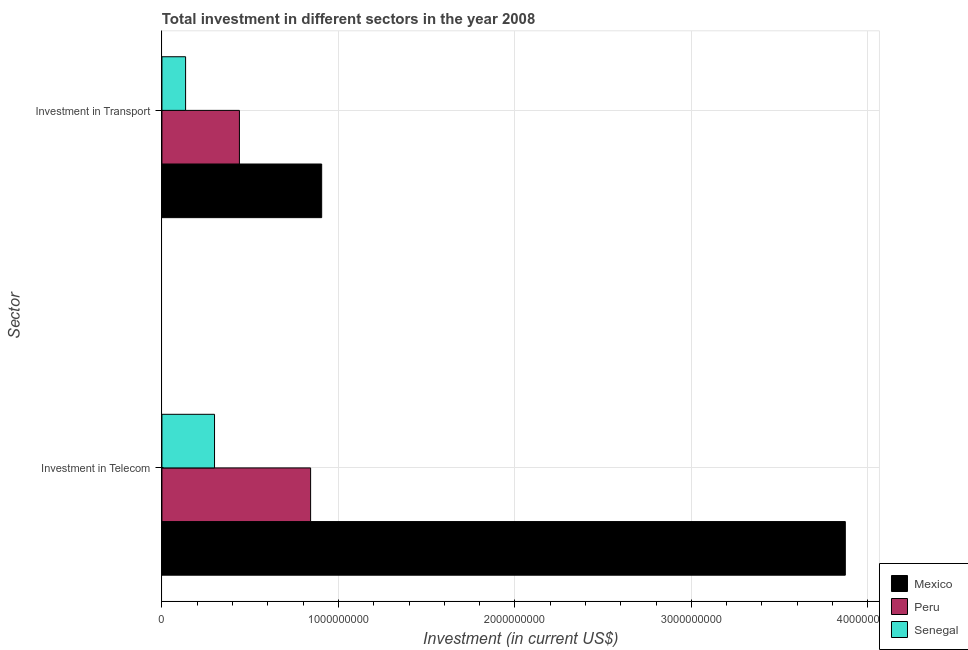How many groups of bars are there?
Give a very brief answer. 2. Are the number of bars per tick equal to the number of legend labels?
Provide a succinct answer. Yes. How many bars are there on the 1st tick from the top?
Give a very brief answer. 3. What is the label of the 2nd group of bars from the top?
Your answer should be compact. Investment in Telecom. What is the investment in telecom in Mexico?
Offer a terse response. 3.87e+09. Across all countries, what is the maximum investment in transport?
Offer a terse response. 9.05e+08. Across all countries, what is the minimum investment in telecom?
Provide a succinct answer. 2.98e+08. In which country was the investment in telecom minimum?
Offer a very short reply. Senegal. What is the total investment in telecom in the graph?
Your answer should be very brief. 5.01e+09. What is the difference between the investment in telecom in Peru and that in Senegal?
Provide a short and direct response. 5.44e+08. What is the difference between the investment in transport in Senegal and the investment in telecom in Peru?
Your answer should be compact. -7.08e+08. What is the average investment in telecom per country?
Your answer should be very brief. 1.67e+09. What is the difference between the investment in telecom and investment in transport in Mexico?
Offer a very short reply. 2.97e+09. What is the ratio of the investment in transport in Peru to that in Senegal?
Your answer should be very brief. 3.28. Is the investment in telecom in Peru less than that in Senegal?
Your response must be concise. No. In how many countries, is the investment in transport greater than the average investment in transport taken over all countries?
Provide a short and direct response. 1. What does the 3rd bar from the top in Investment in Telecom represents?
Your answer should be compact. Mexico. What does the 1st bar from the bottom in Investment in Transport represents?
Offer a terse response. Mexico. What is the difference between two consecutive major ticks on the X-axis?
Offer a very short reply. 1.00e+09. Does the graph contain any zero values?
Give a very brief answer. No. Does the graph contain grids?
Make the answer very short. Yes. Where does the legend appear in the graph?
Make the answer very short. Bottom right. What is the title of the graph?
Offer a very short reply. Total investment in different sectors in the year 2008. What is the label or title of the X-axis?
Provide a succinct answer. Investment (in current US$). What is the label or title of the Y-axis?
Your answer should be compact. Sector. What is the Investment (in current US$) in Mexico in Investment in Telecom?
Your response must be concise. 3.87e+09. What is the Investment (in current US$) in Peru in Investment in Telecom?
Provide a short and direct response. 8.42e+08. What is the Investment (in current US$) in Senegal in Investment in Telecom?
Keep it short and to the point. 2.98e+08. What is the Investment (in current US$) in Mexico in Investment in Transport?
Offer a very short reply. 9.05e+08. What is the Investment (in current US$) of Peru in Investment in Transport?
Provide a short and direct response. 4.39e+08. What is the Investment (in current US$) in Senegal in Investment in Transport?
Keep it short and to the point. 1.34e+08. Across all Sector, what is the maximum Investment (in current US$) of Mexico?
Provide a short and direct response. 3.87e+09. Across all Sector, what is the maximum Investment (in current US$) in Peru?
Your response must be concise. 8.42e+08. Across all Sector, what is the maximum Investment (in current US$) in Senegal?
Provide a succinct answer. 2.98e+08. Across all Sector, what is the minimum Investment (in current US$) of Mexico?
Your answer should be compact. 9.05e+08. Across all Sector, what is the minimum Investment (in current US$) of Peru?
Your answer should be very brief. 4.39e+08. Across all Sector, what is the minimum Investment (in current US$) of Senegal?
Your answer should be very brief. 1.34e+08. What is the total Investment (in current US$) of Mexico in the graph?
Your response must be concise. 4.78e+09. What is the total Investment (in current US$) in Peru in the graph?
Your response must be concise. 1.28e+09. What is the total Investment (in current US$) of Senegal in the graph?
Keep it short and to the point. 4.32e+08. What is the difference between the Investment (in current US$) of Mexico in Investment in Telecom and that in Investment in Transport?
Your response must be concise. 2.97e+09. What is the difference between the Investment (in current US$) of Peru in Investment in Telecom and that in Investment in Transport?
Give a very brief answer. 4.03e+08. What is the difference between the Investment (in current US$) in Senegal in Investment in Telecom and that in Investment in Transport?
Your response must be concise. 1.64e+08. What is the difference between the Investment (in current US$) in Mexico in Investment in Telecom and the Investment (in current US$) in Peru in Investment in Transport?
Give a very brief answer. 3.43e+09. What is the difference between the Investment (in current US$) of Mexico in Investment in Telecom and the Investment (in current US$) of Senegal in Investment in Transport?
Provide a short and direct response. 3.74e+09. What is the difference between the Investment (in current US$) in Peru in Investment in Telecom and the Investment (in current US$) in Senegal in Investment in Transport?
Offer a very short reply. 7.08e+08. What is the average Investment (in current US$) of Mexico per Sector?
Provide a succinct answer. 2.39e+09. What is the average Investment (in current US$) in Peru per Sector?
Give a very brief answer. 6.41e+08. What is the average Investment (in current US$) in Senegal per Sector?
Offer a very short reply. 2.16e+08. What is the difference between the Investment (in current US$) in Mexico and Investment (in current US$) in Peru in Investment in Telecom?
Offer a very short reply. 3.03e+09. What is the difference between the Investment (in current US$) in Mexico and Investment (in current US$) in Senegal in Investment in Telecom?
Give a very brief answer. 3.57e+09. What is the difference between the Investment (in current US$) in Peru and Investment (in current US$) in Senegal in Investment in Telecom?
Your answer should be compact. 5.44e+08. What is the difference between the Investment (in current US$) in Mexico and Investment (in current US$) in Peru in Investment in Transport?
Keep it short and to the point. 4.66e+08. What is the difference between the Investment (in current US$) in Mexico and Investment (in current US$) in Senegal in Investment in Transport?
Ensure brevity in your answer.  7.71e+08. What is the difference between the Investment (in current US$) of Peru and Investment (in current US$) of Senegal in Investment in Transport?
Your answer should be compact. 3.05e+08. What is the ratio of the Investment (in current US$) of Mexico in Investment in Telecom to that in Investment in Transport?
Offer a terse response. 4.28. What is the ratio of the Investment (in current US$) of Peru in Investment in Telecom to that in Investment in Transport?
Give a very brief answer. 1.92. What is the ratio of the Investment (in current US$) of Senegal in Investment in Telecom to that in Investment in Transport?
Your response must be concise. 2.22. What is the difference between the highest and the second highest Investment (in current US$) in Mexico?
Provide a short and direct response. 2.97e+09. What is the difference between the highest and the second highest Investment (in current US$) of Peru?
Give a very brief answer. 4.03e+08. What is the difference between the highest and the second highest Investment (in current US$) of Senegal?
Keep it short and to the point. 1.64e+08. What is the difference between the highest and the lowest Investment (in current US$) in Mexico?
Give a very brief answer. 2.97e+09. What is the difference between the highest and the lowest Investment (in current US$) in Peru?
Provide a short and direct response. 4.03e+08. What is the difference between the highest and the lowest Investment (in current US$) of Senegal?
Provide a succinct answer. 1.64e+08. 